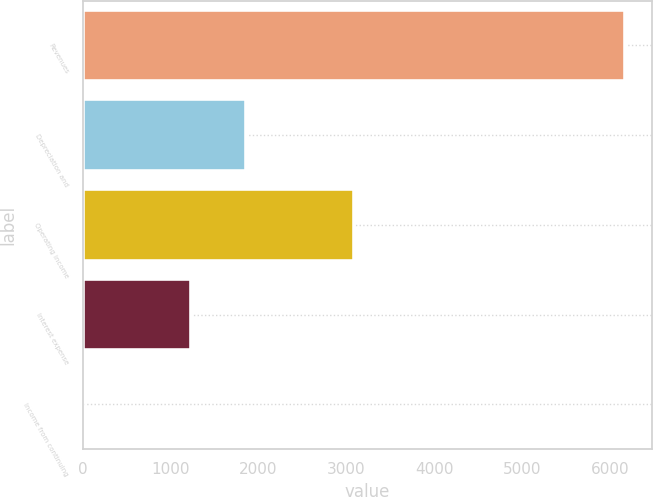Convert chart to OTSL. <chart><loc_0><loc_0><loc_500><loc_500><bar_chart><fcel>Revenues<fcel>Depreciation and<fcel>Operating income<fcel>Interest expense<fcel>Income from continuing<nl><fcel>6172<fcel>1852.69<fcel>3086.79<fcel>1235.64<fcel>1.54<nl></chart> 